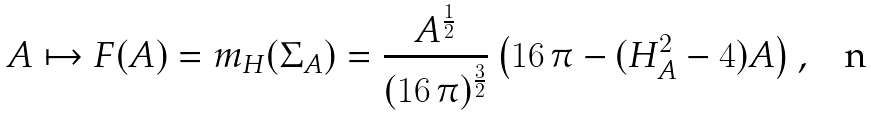Convert formula to latex. <formula><loc_0><loc_0><loc_500><loc_500>A \mapsto F ( A ) = m _ { H } ( \Sigma _ { A } ) = \frac { A ^ { \frac { 1 } { 2 } } } { ( 1 6 \, \pi ) ^ { \frac { 3 } { 2 } } } \left ( 1 6 \, \pi - ( H _ { A } ^ { 2 } - 4 ) A \right ) ,</formula> 